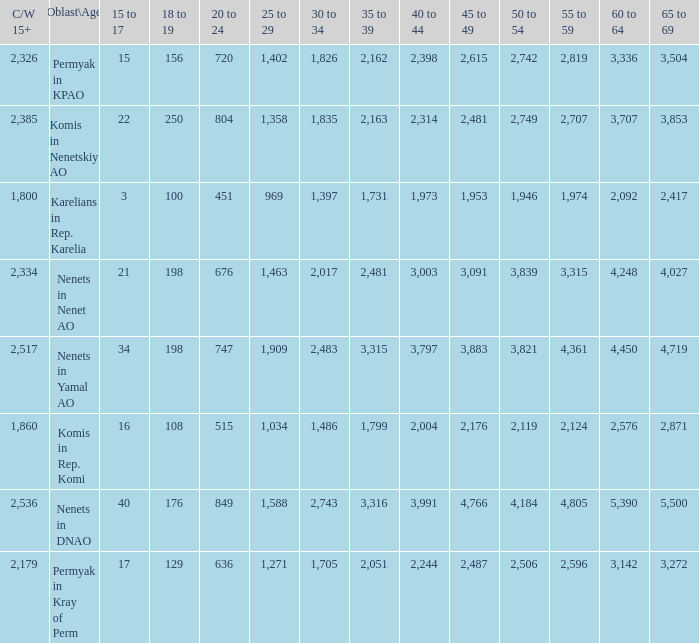With a 20 to 24 less than 676, and a 15 to 17 greater than 16, and a 60 to 64 less than 3,142, what is the average 45 to 49? None. 